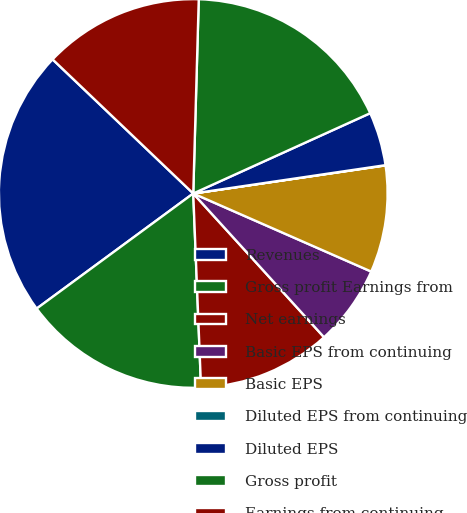<chart> <loc_0><loc_0><loc_500><loc_500><pie_chart><fcel>Revenues<fcel>Gross profit Earnings from<fcel>Net earnings<fcel>Basic EPS from continuing<fcel>Basic EPS<fcel>Diluted EPS from continuing<fcel>Diluted EPS<fcel>Gross profit<fcel>Earnings from continuing<nl><fcel>22.21%<fcel>15.55%<fcel>11.11%<fcel>6.67%<fcel>8.89%<fcel>0.02%<fcel>4.45%<fcel>17.77%<fcel>13.33%<nl></chart> 